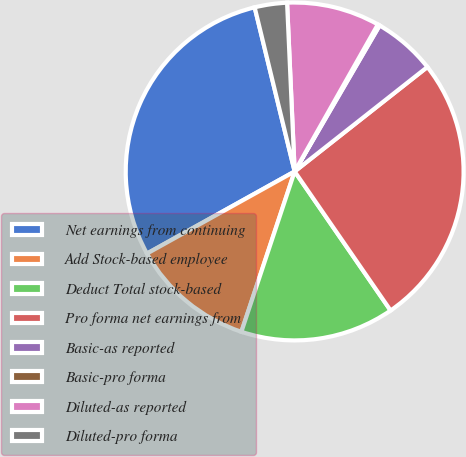<chart> <loc_0><loc_0><loc_500><loc_500><pie_chart><fcel>Net earnings from continuing<fcel>Add Stock-based employee<fcel>Deduct Total stock-based<fcel>Pro forma net earnings from<fcel>Basic-as reported<fcel>Basic-pro forma<fcel>Diluted-as reported<fcel>Diluted-pro forma<nl><fcel>29.27%<fcel>11.82%<fcel>14.72%<fcel>26.0%<fcel>6.0%<fcel>0.19%<fcel>8.91%<fcel>3.09%<nl></chart> 